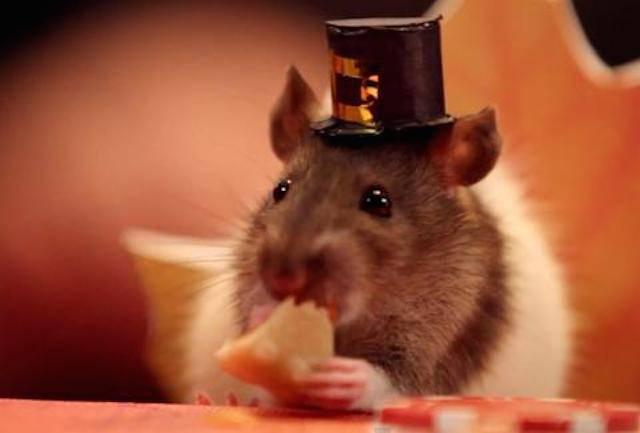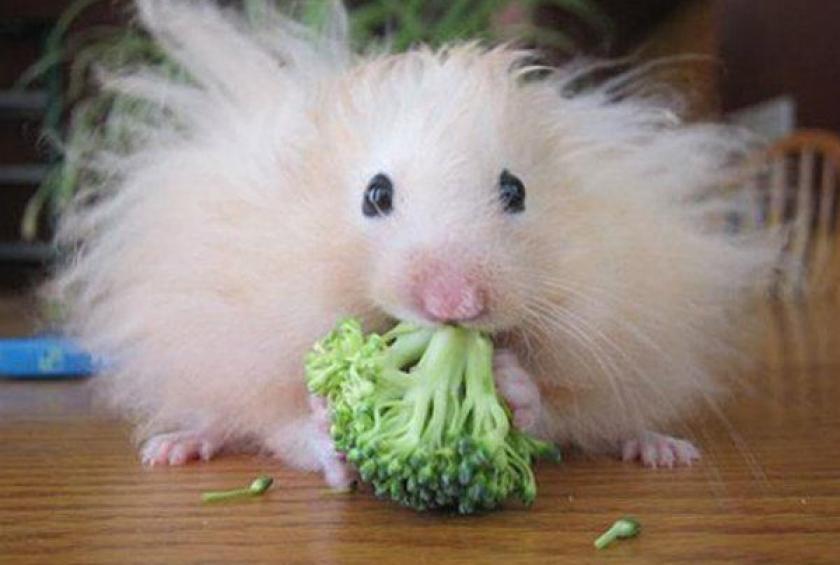The first image is the image on the left, the second image is the image on the right. Assess this claim about the two images: "An image contains a rodent wearing a small hat.". Correct or not? Answer yes or no. Yes. The first image is the image on the left, the second image is the image on the right. Examine the images to the left and right. Is the description "One image shows a hamster in a chair dining at a kind of table and wearing a costume hat." accurate? Answer yes or no. Yes. 